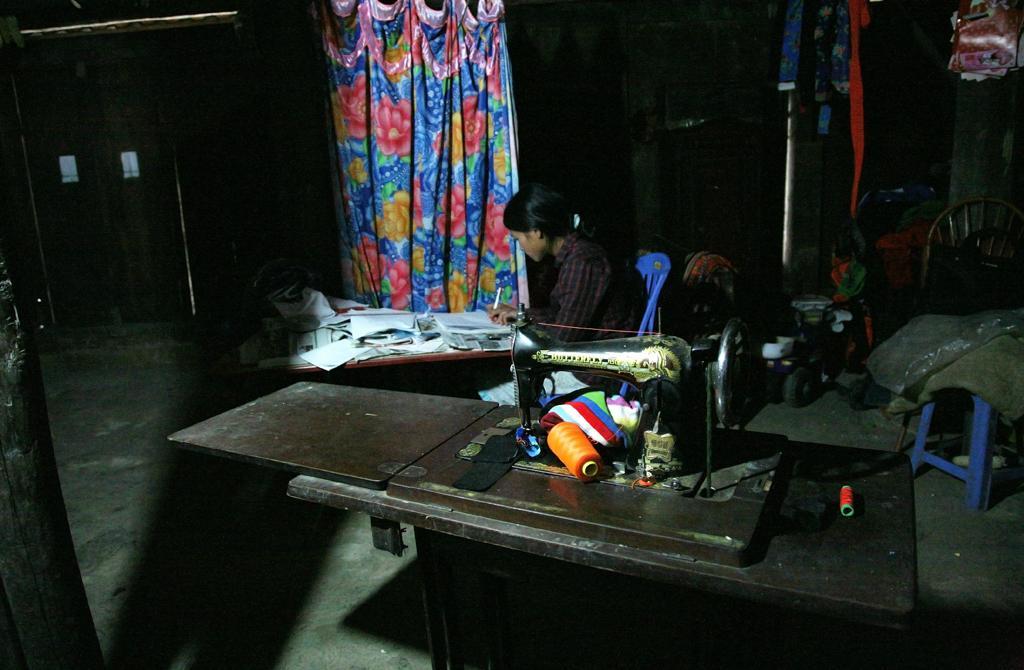Describe this image in one or two sentences. In this image we can see a person sitting on a chair holding the pen and a book beside a table. We can also see some papers on the table. On the bottom of the image we can see a sewing machine and sewing threads on it. On the backside we can see a chair, a door and a curtain. 